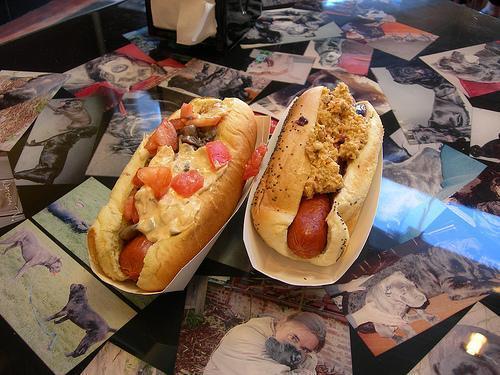How many hot dogs have tomatoes on top as a condiment?
Give a very brief answer. 1. 